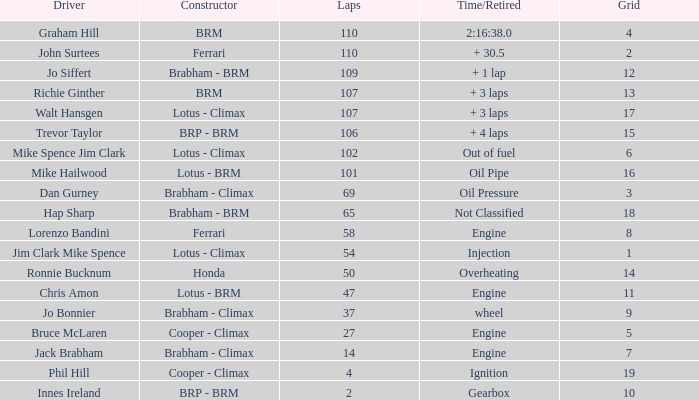Which driver has a time/retired of 2:16:3 Graham Hill. 